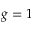Convert formula to latex. <formula><loc_0><loc_0><loc_500><loc_500>g = 1</formula> 